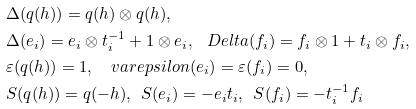Convert formula to latex. <formula><loc_0><loc_0><loc_500><loc_500>& \Delta ( q ( h ) ) = q ( h ) \otimes q ( h ) , \\ & \Delta ( e _ { i } ) = e _ { i } \otimes t _ { i } ^ { - 1 } + 1 \otimes e _ { i } , \ \ \ D e l t a ( f _ { i } ) = f _ { i } \otimes 1 + t _ { i } \otimes f _ { i } , \\ & \varepsilon ( q ( h ) ) = 1 , \quad v a r e p s i l o n ( e _ { i } ) = \varepsilon ( f _ { i } ) = 0 , \\ & S ( q ( h ) ) = q ( - h ) , \ \ S ( e _ { i } ) = - e _ { i } t _ { i } , \ \ S ( f _ { i } ) = - t _ { i } ^ { - 1 } f _ { i }</formula> 